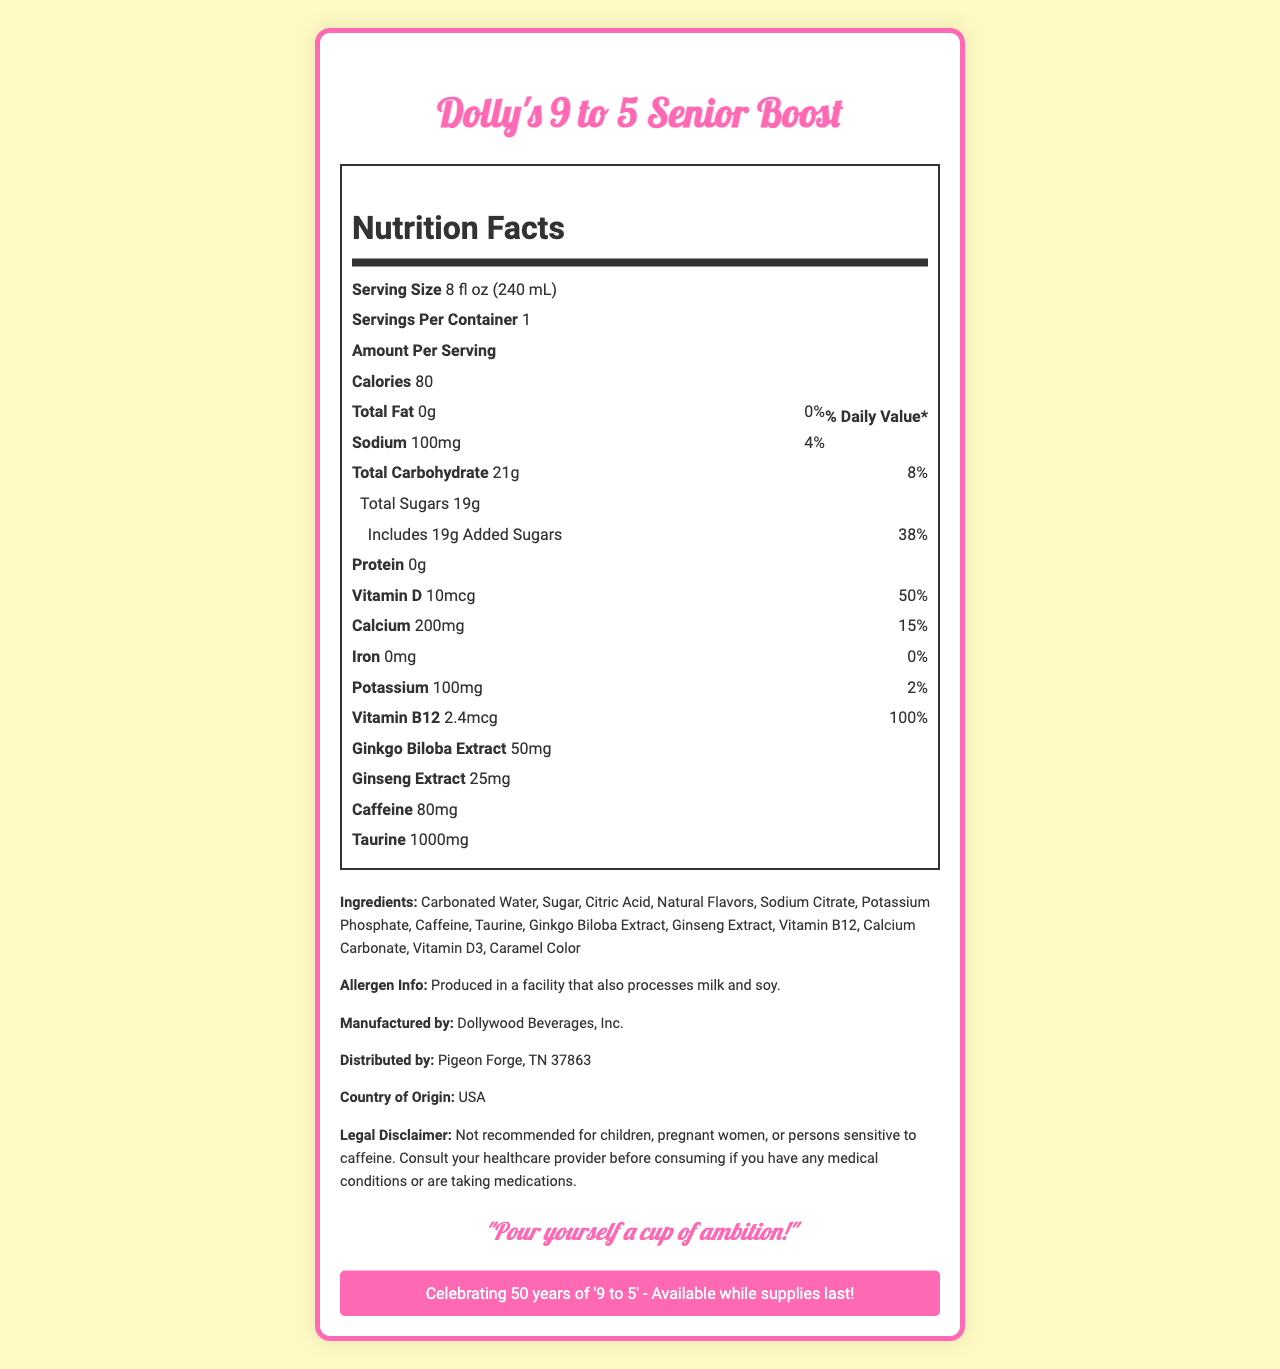what is the serving size? The serving size is listed as "8 fl oz (240 mL)" in the Nutrition Facts section.
Answer: 8 fl oz (240 mL) how many calories are in one serving? According to the Nutrition Facts section, there are 80 calories per serving.
Answer: 80 what percentage of daily value of Vitamin D does this drink contain? The Nutrition Facts section shows that Vitamin D content is 10mcg, which amounts to 50% of the daily value.
Answer: 50% how much added sugar is in the drink? The Nutrition Facts section lists "Includes 19g Added Sugars," which is 38% of the daily value.
Answer: 19g what is the total carbohydrate content in one serving? The total carbohydrate content is listed as 21g, which is 8% of the daily value.
Answer: 21g who is the manufacturer of this drink? The information about the manufacturer is located at the end of the document.
Answer: Dollywood Beverages, Inc. what is the sodium content in one serving? The Nutrition Facts section lists the sodium content as 100mg, which is 4% of the daily value.
Answer: 100mg what is the main ingredient in this drink? A. Caffeine B. Carbonated Water C. Sugar In the ingredients list, "Carbonated Water" is listed first, indicating it is the main ingredient.
Answer: B what percentage of daily value does Vitamin B12 provide? A. 50% B. 15% C. 100% According to the Nutrition Facts, Vitamin B12 content is 2.4mcg, which is 100% of the daily value.
Answer: C is this drink suitable for children? The legal disclaimer states, "Not recommended for children."
Answer: No what message can we find from Dolly Parton in the document? The document includes a quote from Dolly Parton: "Pour yourself a cup of ambition!"
Answer: "Pour yourself a cup of ambition!" summarize the main idea of the document. The document provides comprehensive nutritional details and other important information relevant to the consumer.
Answer: The document is a Nutrition Facts Label for "Dolly's 9 to 5 Senior Boost," a limited edition energy drink celebrating 50 years of Dolly Parton's "9 to 5." It provides detailed nutritional information, ingredients list, allergen info, manufacturer and distributor details, a message from Dolly, and a legal disclaimer warning against consumption by children and certain individuals. how much iron is in one serving of this drink? The Nutrition Facts section states that the iron content is 0mg, which is 0% of the daily value.
Answer: 0mg what is the caffeine content per serving? The Nutrition Facts section indicates that the caffeine content is 80mg per serving.
Answer: 80mg where is this product distributed from? The distribution information states "Pigeon Forge, TN 37863."
Answer: Pigeon Forge, TN 37863 is the limited edition message about celebrating 50 years of "9 to 5"? The limited edition information states, "Celebrating 50 years of '9 to 5' - Available while supplies last!"
Answer: Yes what is the taurine content in this drink? The Nutrition Facts section lists the taurine content as 1000mg.
Answer: 1000mg is there any legal advice in the document regarding people with medical conditions? The legal disclaimer advises, "Consult your healthcare provider before consuming if you have any medical conditions or are taking medications."
Answer: Yes what is the flavor of this drink? The document provides nutritional details and ingredients but does not specify the flavor of the drink.
Answer: Cannot be determined 